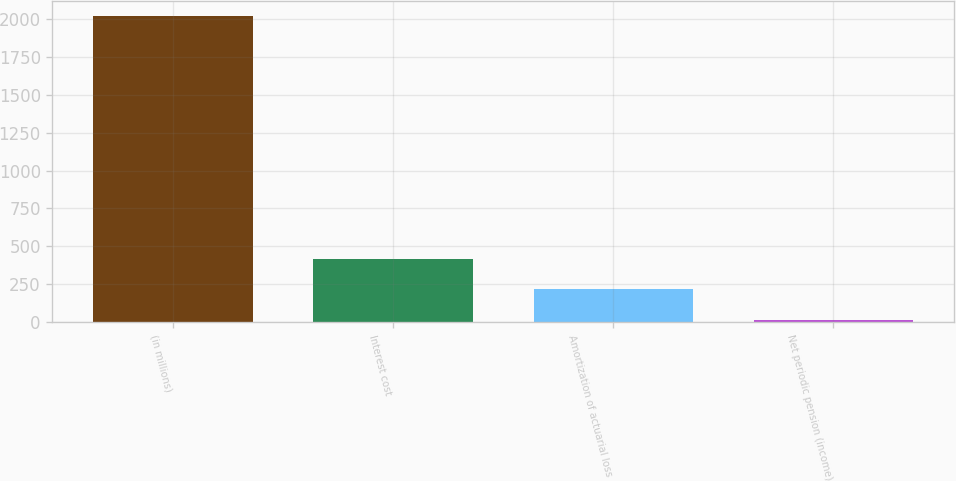Convert chart to OTSL. <chart><loc_0><loc_0><loc_500><loc_500><bar_chart><fcel>(in millions)<fcel>Interest cost<fcel>Amortization of actuarial loss<fcel>Net periodic pension (income)<nl><fcel>2018<fcel>416.4<fcel>216.2<fcel>16<nl></chart> 